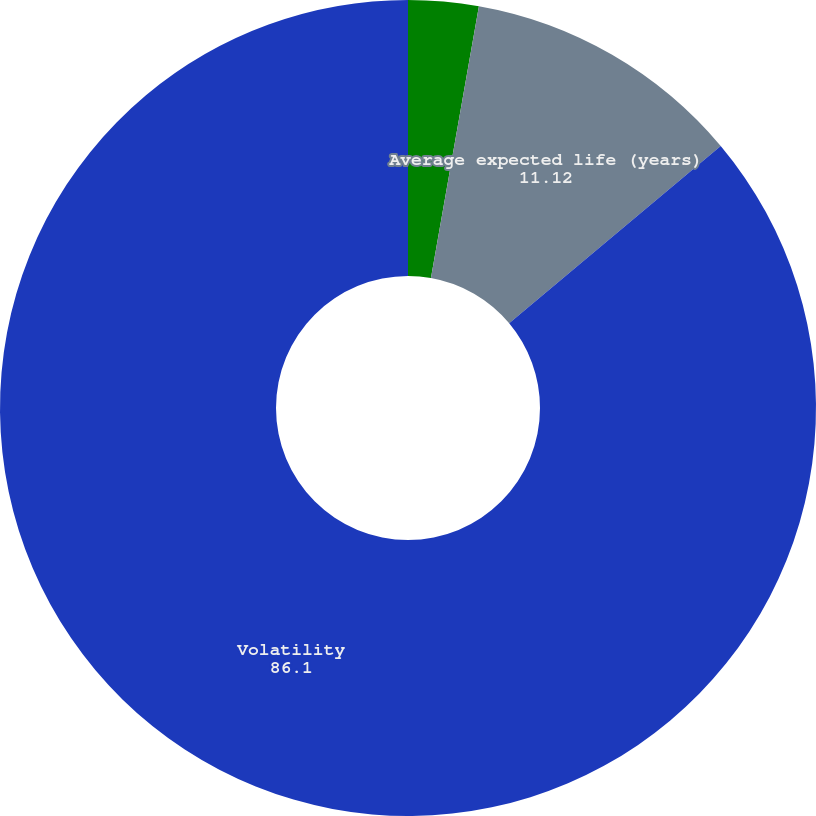Convert chart to OTSL. <chart><loc_0><loc_0><loc_500><loc_500><pie_chart><fcel>Average risk free interest<fcel>Average expected life (years)<fcel>Volatility<nl><fcel>2.78%<fcel>11.12%<fcel>86.1%<nl></chart> 